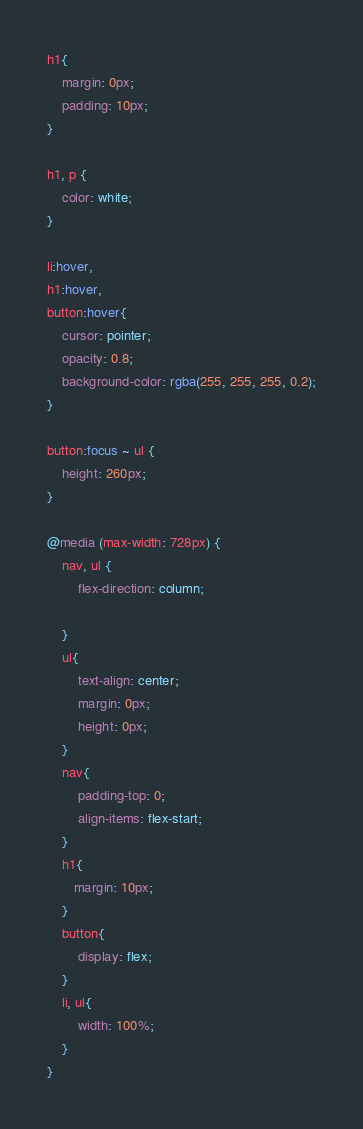<code> <loc_0><loc_0><loc_500><loc_500><_CSS_>
h1{
    margin: 0px;
    padding: 10px;
}

h1, p {
    color: white;
}

li:hover,
h1:hover,
button:hover{
    cursor: pointer;
    opacity: 0.8;
    background-color: rgba(255, 255, 255, 0.2);
}

button:focus ~ ul {
    height: 260px;
}

@media (max-width: 728px) {
    nav, ul {
        flex-direction: column;

    }
    ul{
        text-align: center;
        margin: 0px;
        height: 0px;
    }
    nav{
        padding-top: 0;
        align-items: flex-start;
    }
    h1{
       margin: 10px;
    }
    button{
        display: flex;
    }
    li, ul{
        width: 100%;
    }
}

</code> 